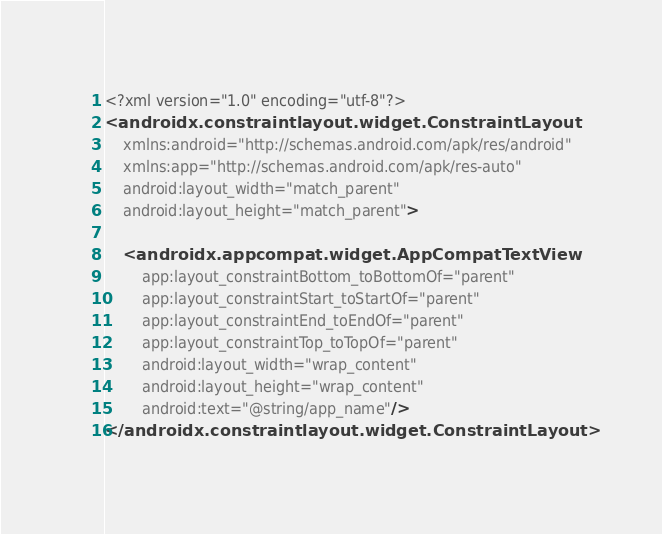<code> <loc_0><loc_0><loc_500><loc_500><_XML_><?xml version="1.0" encoding="utf-8"?>
<androidx.constraintlayout.widget.ConstraintLayout
    xmlns:android="http://schemas.android.com/apk/res/android"
    xmlns:app="http://schemas.android.com/apk/res-auto"
    android:layout_width="match_parent"
    android:layout_height="match_parent">

    <androidx.appcompat.widget.AppCompatTextView
        app:layout_constraintBottom_toBottomOf="parent"
        app:layout_constraintStart_toStartOf="parent"
        app:layout_constraintEnd_toEndOf="parent"
        app:layout_constraintTop_toTopOf="parent"
        android:layout_width="wrap_content"
        android:layout_height="wrap_content"
        android:text="@string/app_name"/>
</androidx.constraintlayout.widget.ConstraintLayout></code> 